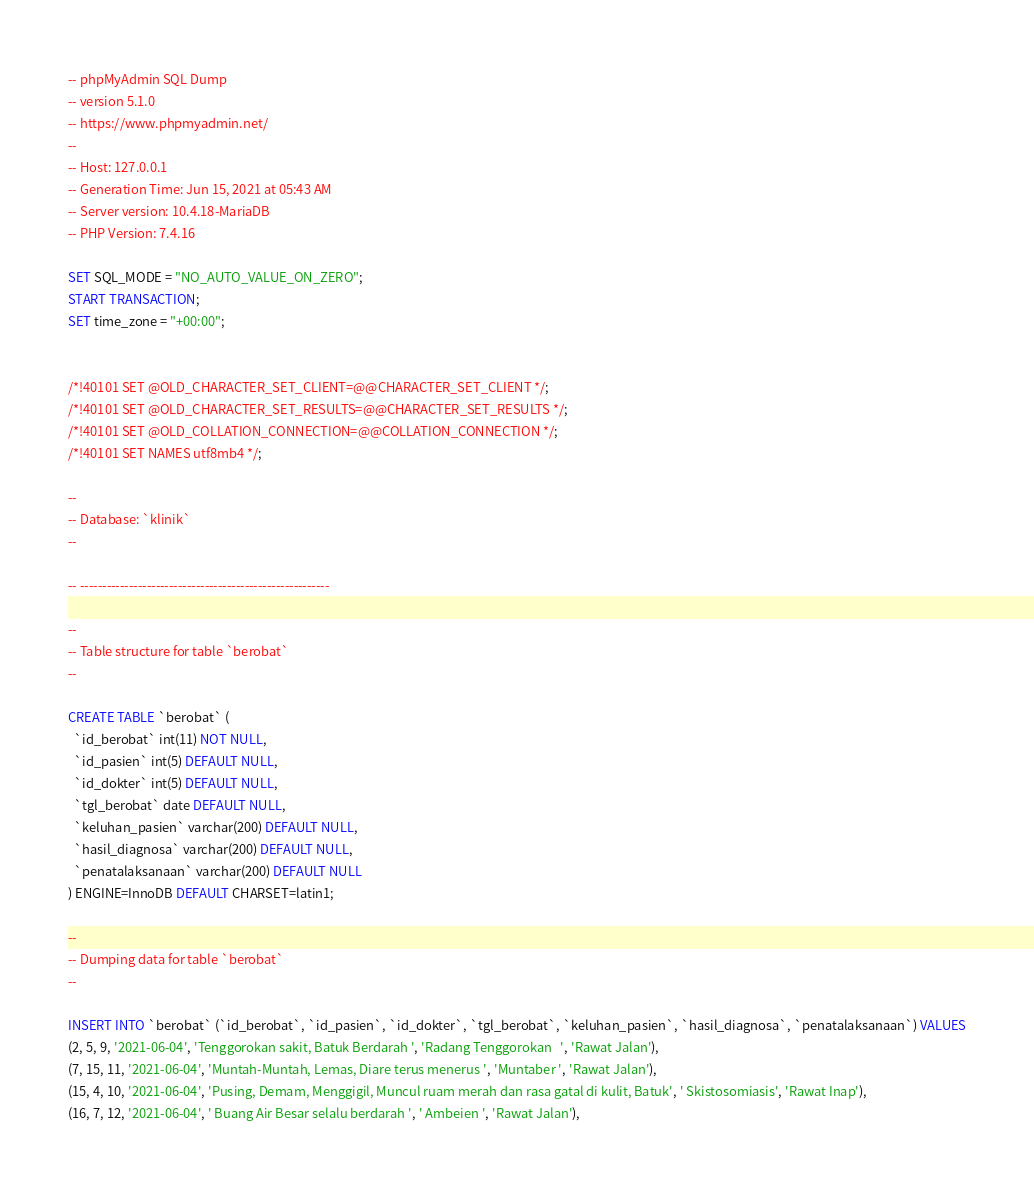Convert code to text. <code><loc_0><loc_0><loc_500><loc_500><_SQL_>-- phpMyAdmin SQL Dump
-- version 5.1.0
-- https://www.phpmyadmin.net/
--
-- Host: 127.0.0.1
-- Generation Time: Jun 15, 2021 at 05:43 AM
-- Server version: 10.4.18-MariaDB
-- PHP Version: 7.4.16

SET SQL_MODE = "NO_AUTO_VALUE_ON_ZERO";
START TRANSACTION;
SET time_zone = "+00:00";


/*!40101 SET @OLD_CHARACTER_SET_CLIENT=@@CHARACTER_SET_CLIENT */;
/*!40101 SET @OLD_CHARACTER_SET_RESULTS=@@CHARACTER_SET_RESULTS */;
/*!40101 SET @OLD_COLLATION_CONNECTION=@@COLLATION_CONNECTION */;
/*!40101 SET NAMES utf8mb4 */;

--
-- Database: `klinik`
--

-- --------------------------------------------------------

--
-- Table structure for table `berobat`
--

CREATE TABLE `berobat` (
  `id_berobat` int(11) NOT NULL,
  `id_pasien` int(5) DEFAULT NULL,
  `id_dokter` int(5) DEFAULT NULL,
  `tgl_berobat` date DEFAULT NULL,
  `keluhan_pasien` varchar(200) DEFAULT NULL,
  `hasil_diagnosa` varchar(200) DEFAULT NULL,
  `penatalaksanaan` varchar(200) DEFAULT NULL
) ENGINE=InnoDB DEFAULT CHARSET=latin1;

--
-- Dumping data for table `berobat`
--

INSERT INTO `berobat` (`id_berobat`, `id_pasien`, `id_dokter`, `tgl_berobat`, `keluhan_pasien`, `hasil_diagnosa`, `penatalaksanaan`) VALUES
(2, 5, 9, '2021-06-04', 'Tenggorokan sakit, Batuk Berdarah ', 'Radang Tenggorokan   ', 'Rawat Jalan'),
(7, 15, 11, '2021-06-04', 'Muntah-Muntah, Lemas, Diare terus menerus ', 'Muntaber ', 'Rawat Jalan'),
(15, 4, 10, '2021-06-04', 'Pusing, Demam, Menggigil, Muncul ruam merah dan rasa gatal di kulit, Batuk', ' Skistosomiasis', 'Rawat Inap'),
(16, 7, 12, '2021-06-04', ' Buang Air Besar selalu berdarah ', ' Ambeien ', 'Rawat Jalan'),</code> 